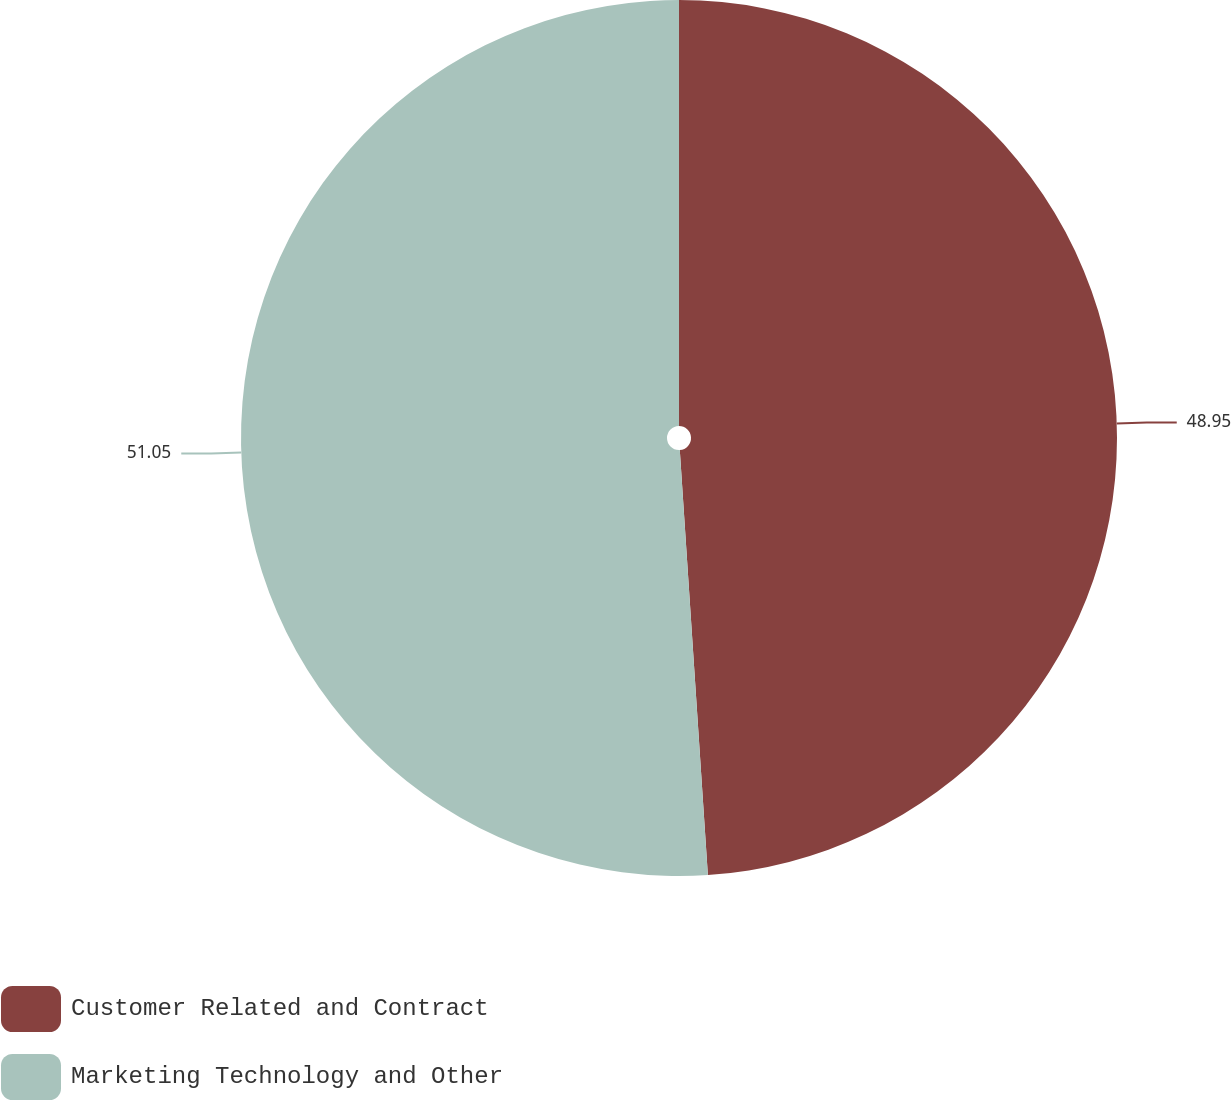Convert chart. <chart><loc_0><loc_0><loc_500><loc_500><pie_chart><fcel>Customer Related and Contract<fcel>Marketing Technology and Other<nl><fcel>48.95%<fcel>51.05%<nl></chart> 